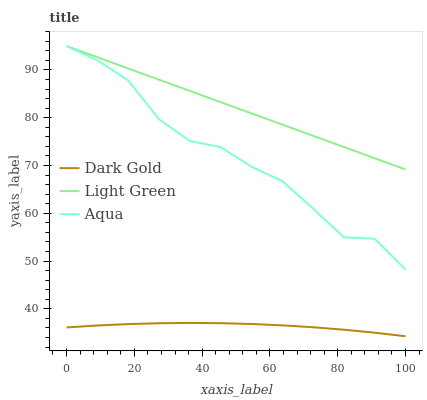Does Dark Gold have the minimum area under the curve?
Answer yes or no. Yes. Does Light Green have the minimum area under the curve?
Answer yes or no. No. Does Dark Gold have the maximum area under the curve?
Answer yes or no. No. Is Dark Gold the smoothest?
Answer yes or no. No. Is Dark Gold the roughest?
Answer yes or no. No. Does Light Green have the lowest value?
Answer yes or no. No. Does Dark Gold have the highest value?
Answer yes or no. No. Is Dark Gold less than Light Green?
Answer yes or no. Yes. Is Aqua greater than Dark Gold?
Answer yes or no. Yes. Does Dark Gold intersect Light Green?
Answer yes or no. No. 